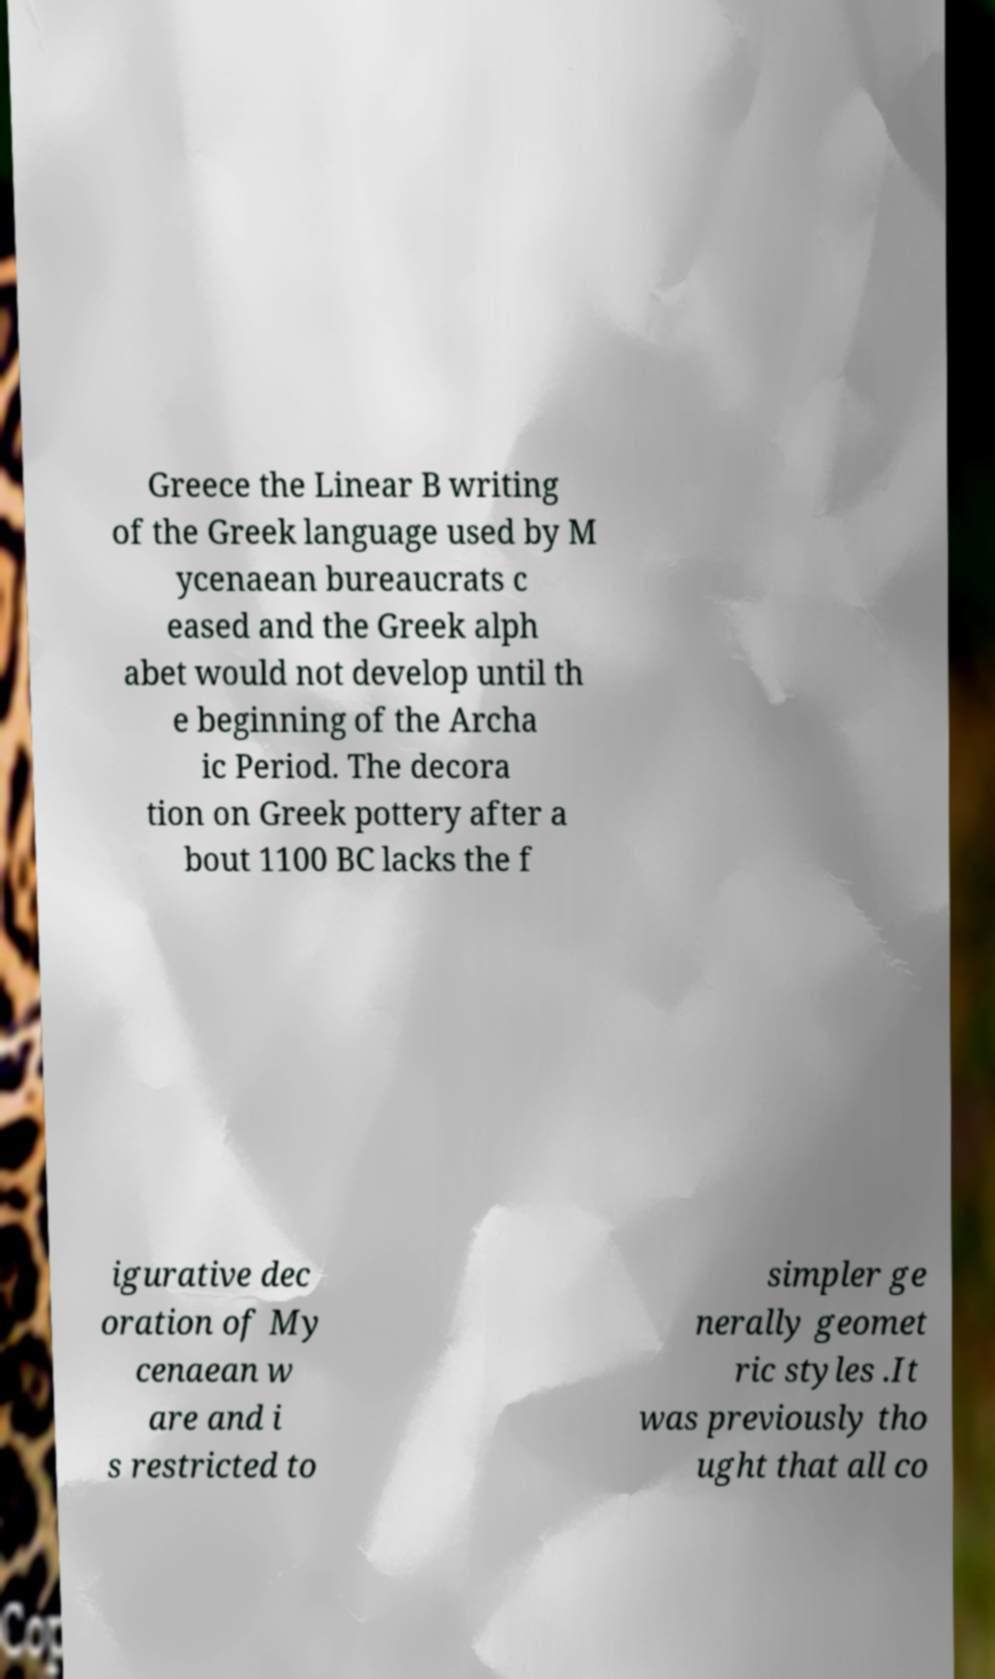Could you assist in decoding the text presented in this image and type it out clearly? Greece the Linear B writing of the Greek language used by M ycenaean bureaucrats c eased and the Greek alph abet would not develop until th e beginning of the Archa ic Period. The decora tion on Greek pottery after a bout 1100 BC lacks the f igurative dec oration of My cenaean w are and i s restricted to simpler ge nerally geomet ric styles .It was previously tho ught that all co 